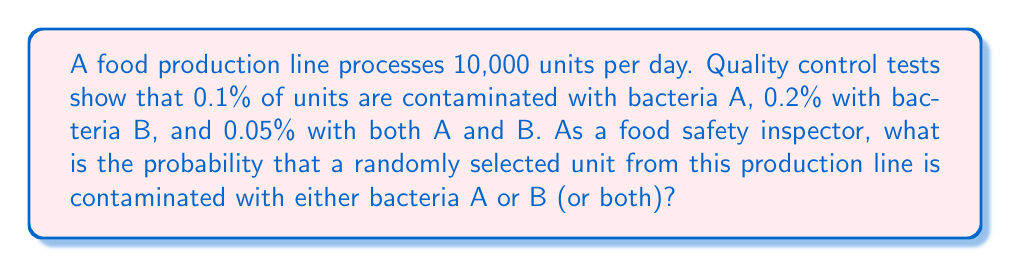Solve this math problem. To solve this problem, we'll use the concept of probability of union of events. Let's follow these steps:

1. Define events:
   Let A = event that a unit is contaminated with bacteria A
   Let B = event that a unit is contaminated with bacteria B

2. Given probabilities:
   P(A) = 0.1% = 0.001
   P(B) = 0.2% = 0.002
   P(A ∩ B) = 0.05% = 0.0005 (probability of both A and B occurring)

3. Use the formula for the probability of union of two events:
   P(A ∪ B) = P(A) + P(B) - P(A ∩ B)

4. Substitute the values:
   P(A ∪ B) = 0.001 + 0.002 - 0.0005

5. Calculate:
   P(A ∪ B) = 0.0025

6. Convert to percentage:
   0.0025 * 100 = 0.25%

Therefore, the probability that a randomly selected unit is contaminated with either bacteria A or B (or both) is 0.25% or 0.0025.
Answer: 0.25% 